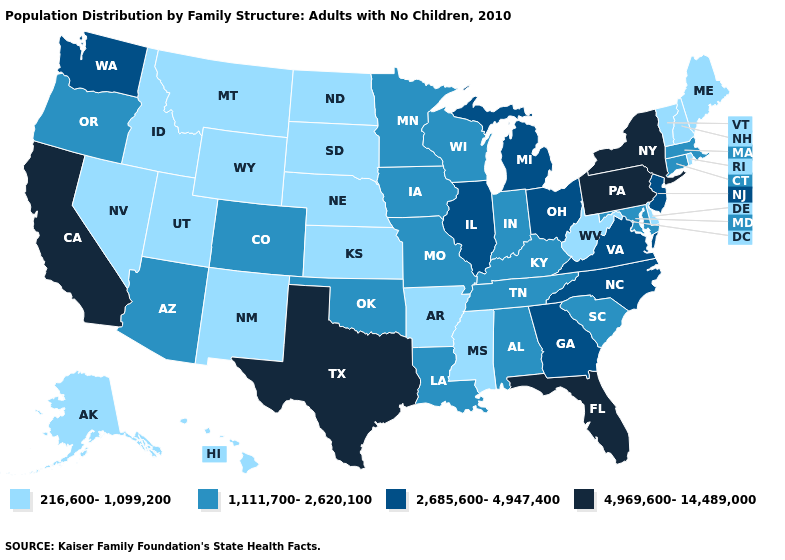What is the value of Utah?
Short answer required. 216,600-1,099,200. Does New York have the lowest value in the USA?
Be succinct. No. How many symbols are there in the legend?
Concise answer only. 4. Name the states that have a value in the range 216,600-1,099,200?
Quick response, please. Alaska, Arkansas, Delaware, Hawaii, Idaho, Kansas, Maine, Mississippi, Montana, Nebraska, Nevada, New Hampshire, New Mexico, North Dakota, Rhode Island, South Dakota, Utah, Vermont, West Virginia, Wyoming. Among the states that border Kansas , which have the highest value?
Give a very brief answer. Colorado, Missouri, Oklahoma. Does New Hampshire have a lower value than Vermont?
Write a very short answer. No. Name the states that have a value in the range 4,969,600-14,489,000?
Short answer required. California, Florida, New York, Pennsylvania, Texas. What is the value of Connecticut?
Give a very brief answer. 1,111,700-2,620,100. Name the states that have a value in the range 216,600-1,099,200?
Answer briefly. Alaska, Arkansas, Delaware, Hawaii, Idaho, Kansas, Maine, Mississippi, Montana, Nebraska, Nevada, New Hampshire, New Mexico, North Dakota, Rhode Island, South Dakota, Utah, Vermont, West Virginia, Wyoming. What is the highest value in the MidWest ?
Write a very short answer. 2,685,600-4,947,400. Name the states that have a value in the range 4,969,600-14,489,000?
Keep it brief. California, Florida, New York, Pennsylvania, Texas. Which states have the lowest value in the USA?
Answer briefly. Alaska, Arkansas, Delaware, Hawaii, Idaho, Kansas, Maine, Mississippi, Montana, Nebraska, Nevada, New Hampshire, New Mexico, North Dakota, Rhode Island, South Dakota, Utah, Vermont, West Virginia, Wyoming. Name the states that have a value in the range 4,969,600-14,489,000?
Concise answer only. California, Florida, New York, Pennsylvania, Texas. What is the value of New Mexico?
Keep it brief. 216,600-1,099,200. Name the states that have a value in the range 1,111,700-2,620,100?
Concise answer only. Alabama, Arizona, Colorado, Connecticut, Indiana, Iowa, Kentucky, Louisiana, Maryland, Massachusetts, Minnesota, Missouri, Oklahoma, Oregon, South Carolina, Tennessee, Wisconsin. 